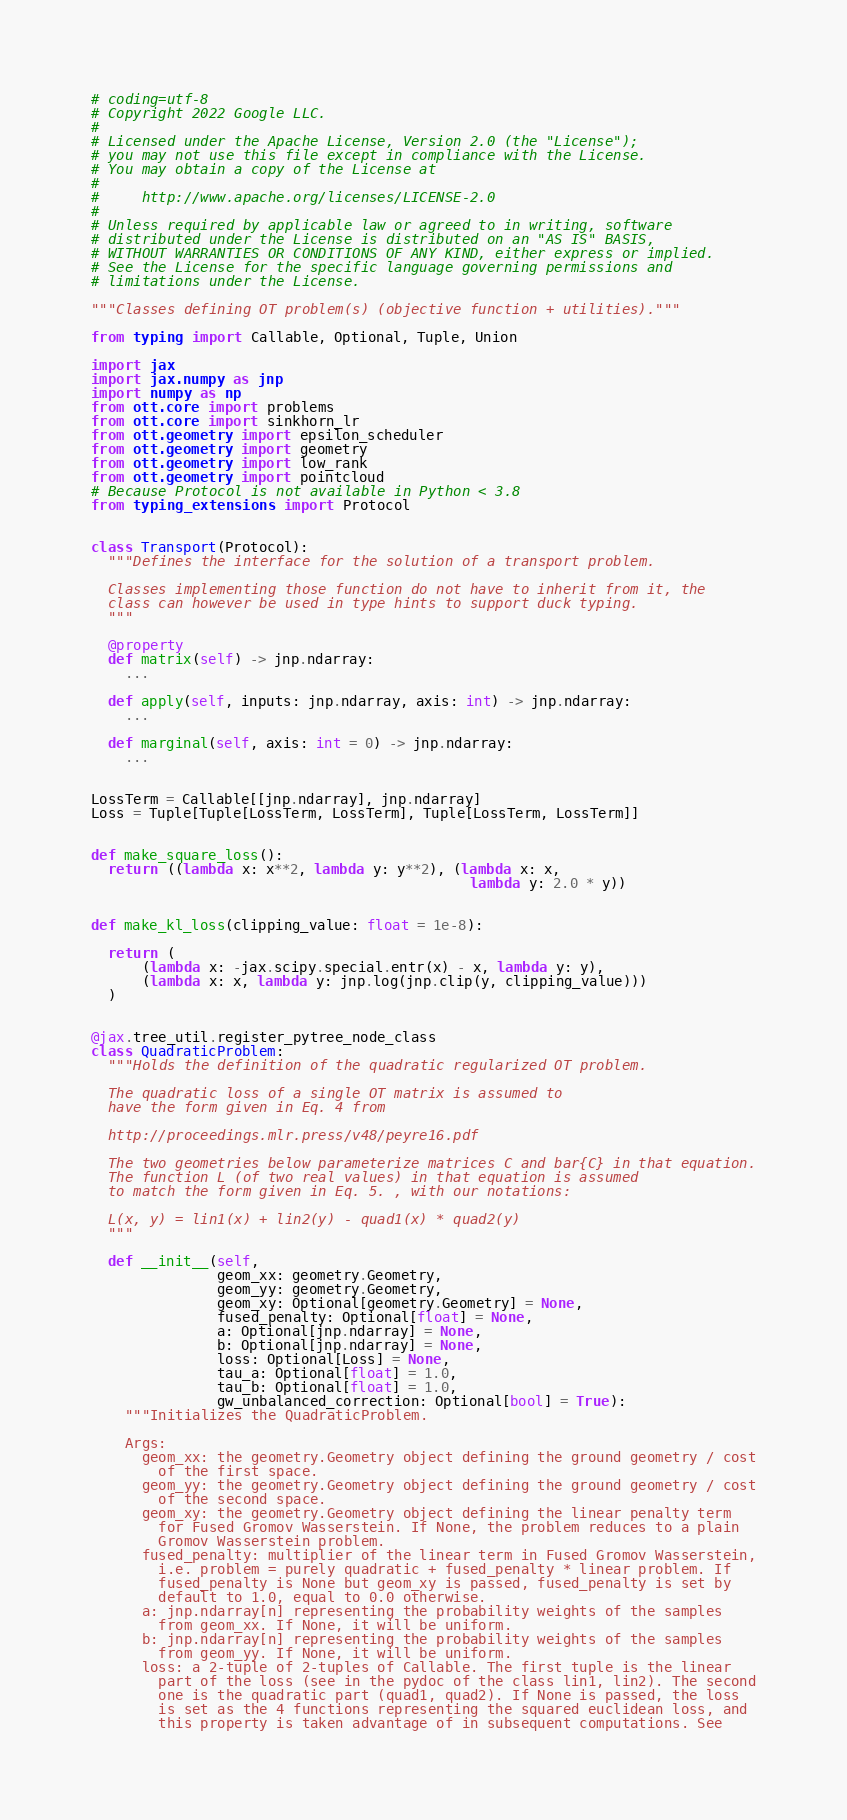<code> <loc_0><loc_0><loc_500><loc_500><_Python_># coding=utf-8
# Copyright 2022 Google LLC.
#
# Licensed under the Apache License, Version 2.0 (the "License");
# you may not use this file except in compliance with the License.
# You may obtain a copy of the License at
#
#     http://www.apache.org/licenses/LICENSE-2.0
#
# Unless required by applicable law or agreed to in writing, software
# distributed under the License is distributed on an "AS IS" BASIS,
# WITHOUT WARRANTIES OR CONDITIONS OF ANY KIND, either express or implied.
# See the License for the specific language governing permissions and
# limitations under the License.

"""Classes defining OT problem(s) (objective function + utilities)."""

from typing import Callable, Optional, Tuple, Union

import jax
import jax.numpy as jnp
import numpy as np
from ott.core import problems
from ott.core import sinkhorn_lr
from ott.geometry import epsilon_scheduler
from ott.geometry import geometry
from ott.geometry import low_rank
from ott.geometry import pointcloud
# Because Protocol is not available in Python < 3.8
from typing_extensions import Protocol


class Transport(Protocol):
  """Defines the interface for the solution of a transport problem.

  Classes implementing those function do not have to inherit from it, the
  class can however be used in type hints to support duck typing.
  """

  @property
  def matrix(self) -> jnp.ndarray:
    ...

  def apply(self, inputs: jnp.ndarray, axis: int) -> jnp.ndarray:
    ...

  def marginal(self, axis: int = 0) -> jnp.ndarray:
    ...


LossTerm = Callable[[jnp.ndarray], jnp.ndarray]
Loss = Tuple[Tuple[LossTerm, LossTerm], Tuple[LossTerm, LossTerm]]


def make_square_loss():
  return ((lambda x: x**2, lambda y: y**2), (lambda x: x,
                                             lambda y: 2.0 * y))


def make_kl_loss(clipping_value: float = 1e-8):

  return (
      (lambda x: -jax.scipy.special.entr(x) - x, lambda y: y),
      (lambda x: x, lambda y: jnp.log(jnp.clip(y, clipping_value)))
  )


@jax.tree_util.register_pytree_node_class
class QuadraticProblem:
  """Holds the definition of the quadratic regularized OT problem.

  The quadratic loss of a single OT matrix is assumed to
  have the form given in Eq. 4 from

  http://proceedings.mlr.press/v48/peyre16.pdf

  The two geometries below parameterize matrices C and bar{C} in that equation.
  The function L (of two real values) in that equation is assumed
  to match the form given in Eq. 5. , with our notations:

  L(x, y) = lin1(x) + lin2(y) - quad1(x) * quad2(y)
  """

  def __init__(self,
               geom_xx: geometry.Geometry,
               geom_yy: geometry.Geometry,
               geom_xy: Optional[geometry.Geometry] = None,
               fused_penalty: Optional[float] = None,
               a: Optional[jnp.ndarray] = None,
               b: Optional[jnp.ndarray] = None,
               loss: Optional[Loss] = None,
               tau_a: Optional[float] = 1.0,
               tau_b: Optional[float] = 1.0,
               gw_unbalanced_correction: Optional[bool] = True):
    """Initializes the QuadraticProblem.

    Args:
      geom_xx: the geometry.Geometry object defining the ground geometry / cost
        of the first space.
      geom_yy: the geometry.Geometry object defining the ground geometry / cost
        of the second space.
      geom_xy: the geometry.Geometry object defining the linear penalty term
        for Fused Gromov Wasserstein. If None, the problem reduces to a plain
        Gromov Wasserstein problem.
      fused_penalty: multiplier of the linear term in Fused Gromov Wasserstein,
        i.e. problem = purely quadratic + fused_penalty * linear problem. If
        fused_penalty is None but geom_xy is passed, fused_penalty is set by
        default to 1.0, equal to 0.0 otherwise.
      a: jnp.ndarray[n] representing the probability weights of the samples
        from geom_xx. If None, it will be uniform.
      b: jnp.ndarray[n] representing the probability weights of the samples
        from geom_yy. If None, it will be uniform.
      loss: a 2-tuple of 2-tuples of Callable. The first tuple is the linear
        part of the loss (see in the pydoc of the class lin1, lin2). The second
        one is the quadratic part (quad1, quad2). If None is passed, the loss
        is set as the 4 functions representing the squared euclidean loss, and
        this property is taken advantage of in subsequent computations. See</code> 